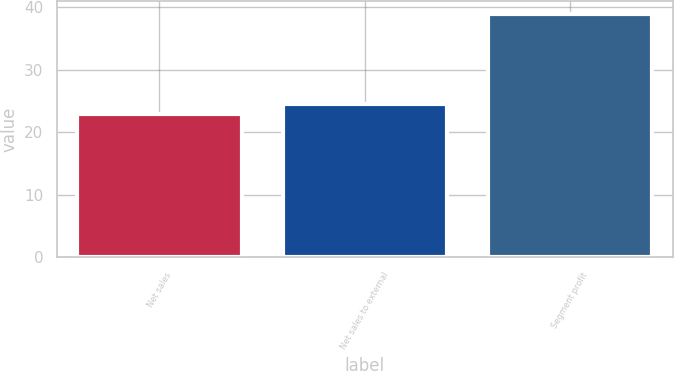Convert chart. <chart><loc_0><loc_0><loc_500><loc_500><bar_chart><fcel>Net sales<fcel>Net sales to external<fcel>Segment profit<nl><fcel>23<fcel>24.6<fcel>39<nl></chart> 